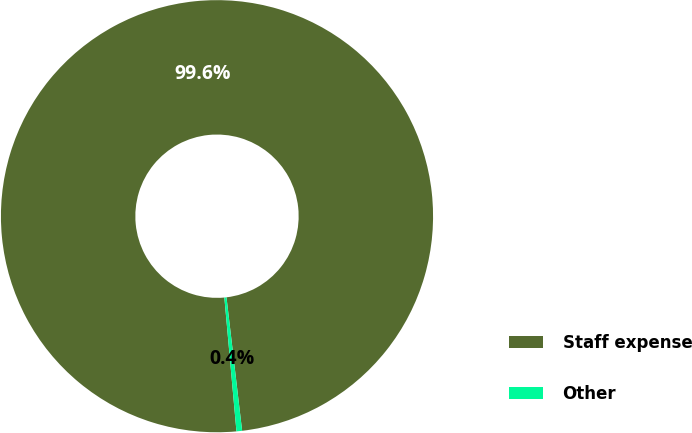Convert chart to OTSL. <chart><loc_0><loc_0><loc_500><loc_500><pie_chart><fcel>Staff expense<fcel>Other<nl><fcel>99.58%<fcel>0.42%<nl></chart> 